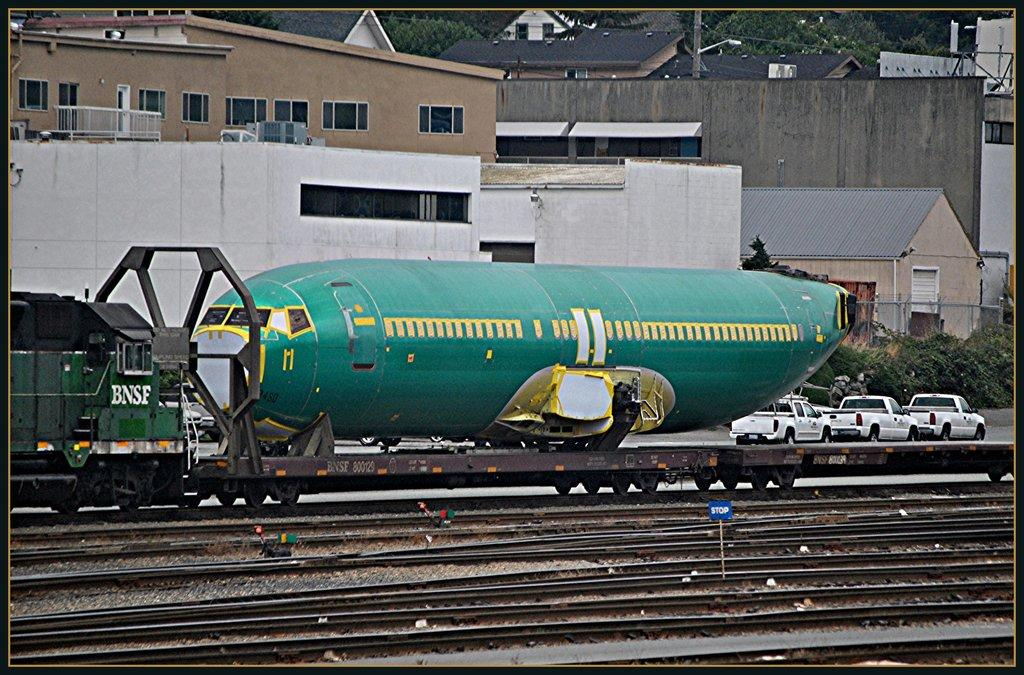<image>
Present a compact description of the photo's key features. A BNSF railroad engine pulling a plane fuselage 